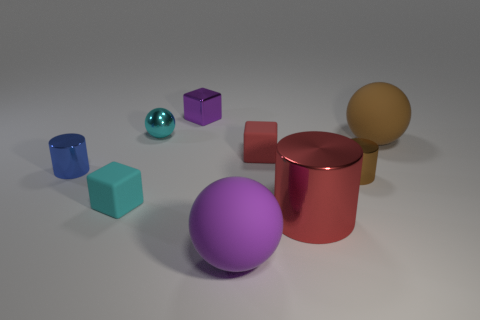There is a object that is the same color as the metallic cube; what size is it?
Your response must be concise. Large. There is a cyan rubber object behind the large thing in front of the large shiny object; what is its shape?
Give a very brief answer. Cube. There is a big brown thing; is it the same shape as the small object to the right of the red matte block?
Provide a succinct answer. No. There is a ball that is the same size as the purple metallic object; what is its color?
Provide a short and direct response. Cyan. Are there fewer purple rubber balls on the right side of the purple matte ball than tiny metal cylinders that are on the left side of the small cyan shiny thing?
Ensure brevity in your answer.  Yes. The big brown object that is right of the cylinder in front of the small cylinder right of the big purple object is what shape?
Give a very brief answer. Sphere. There is a small cube that is behind the tiny cyan shiny thing; is it the same color as the rubber sphere to the right of the small brown metallic thing?
Ensure brevity in your answer.  No. There is a matte object that is the same color as the small shiny block; what shape is it?
Offer a terse response. Sphere. What number of rubber things are either cyan spheres or cyan things?
Provide a succinct answer. 1. What color is the tiny shiny object that is in front of the cylinder behind the small metal cylinder on the right side of the big purple thing?
Your answer should be compact. Brown. 